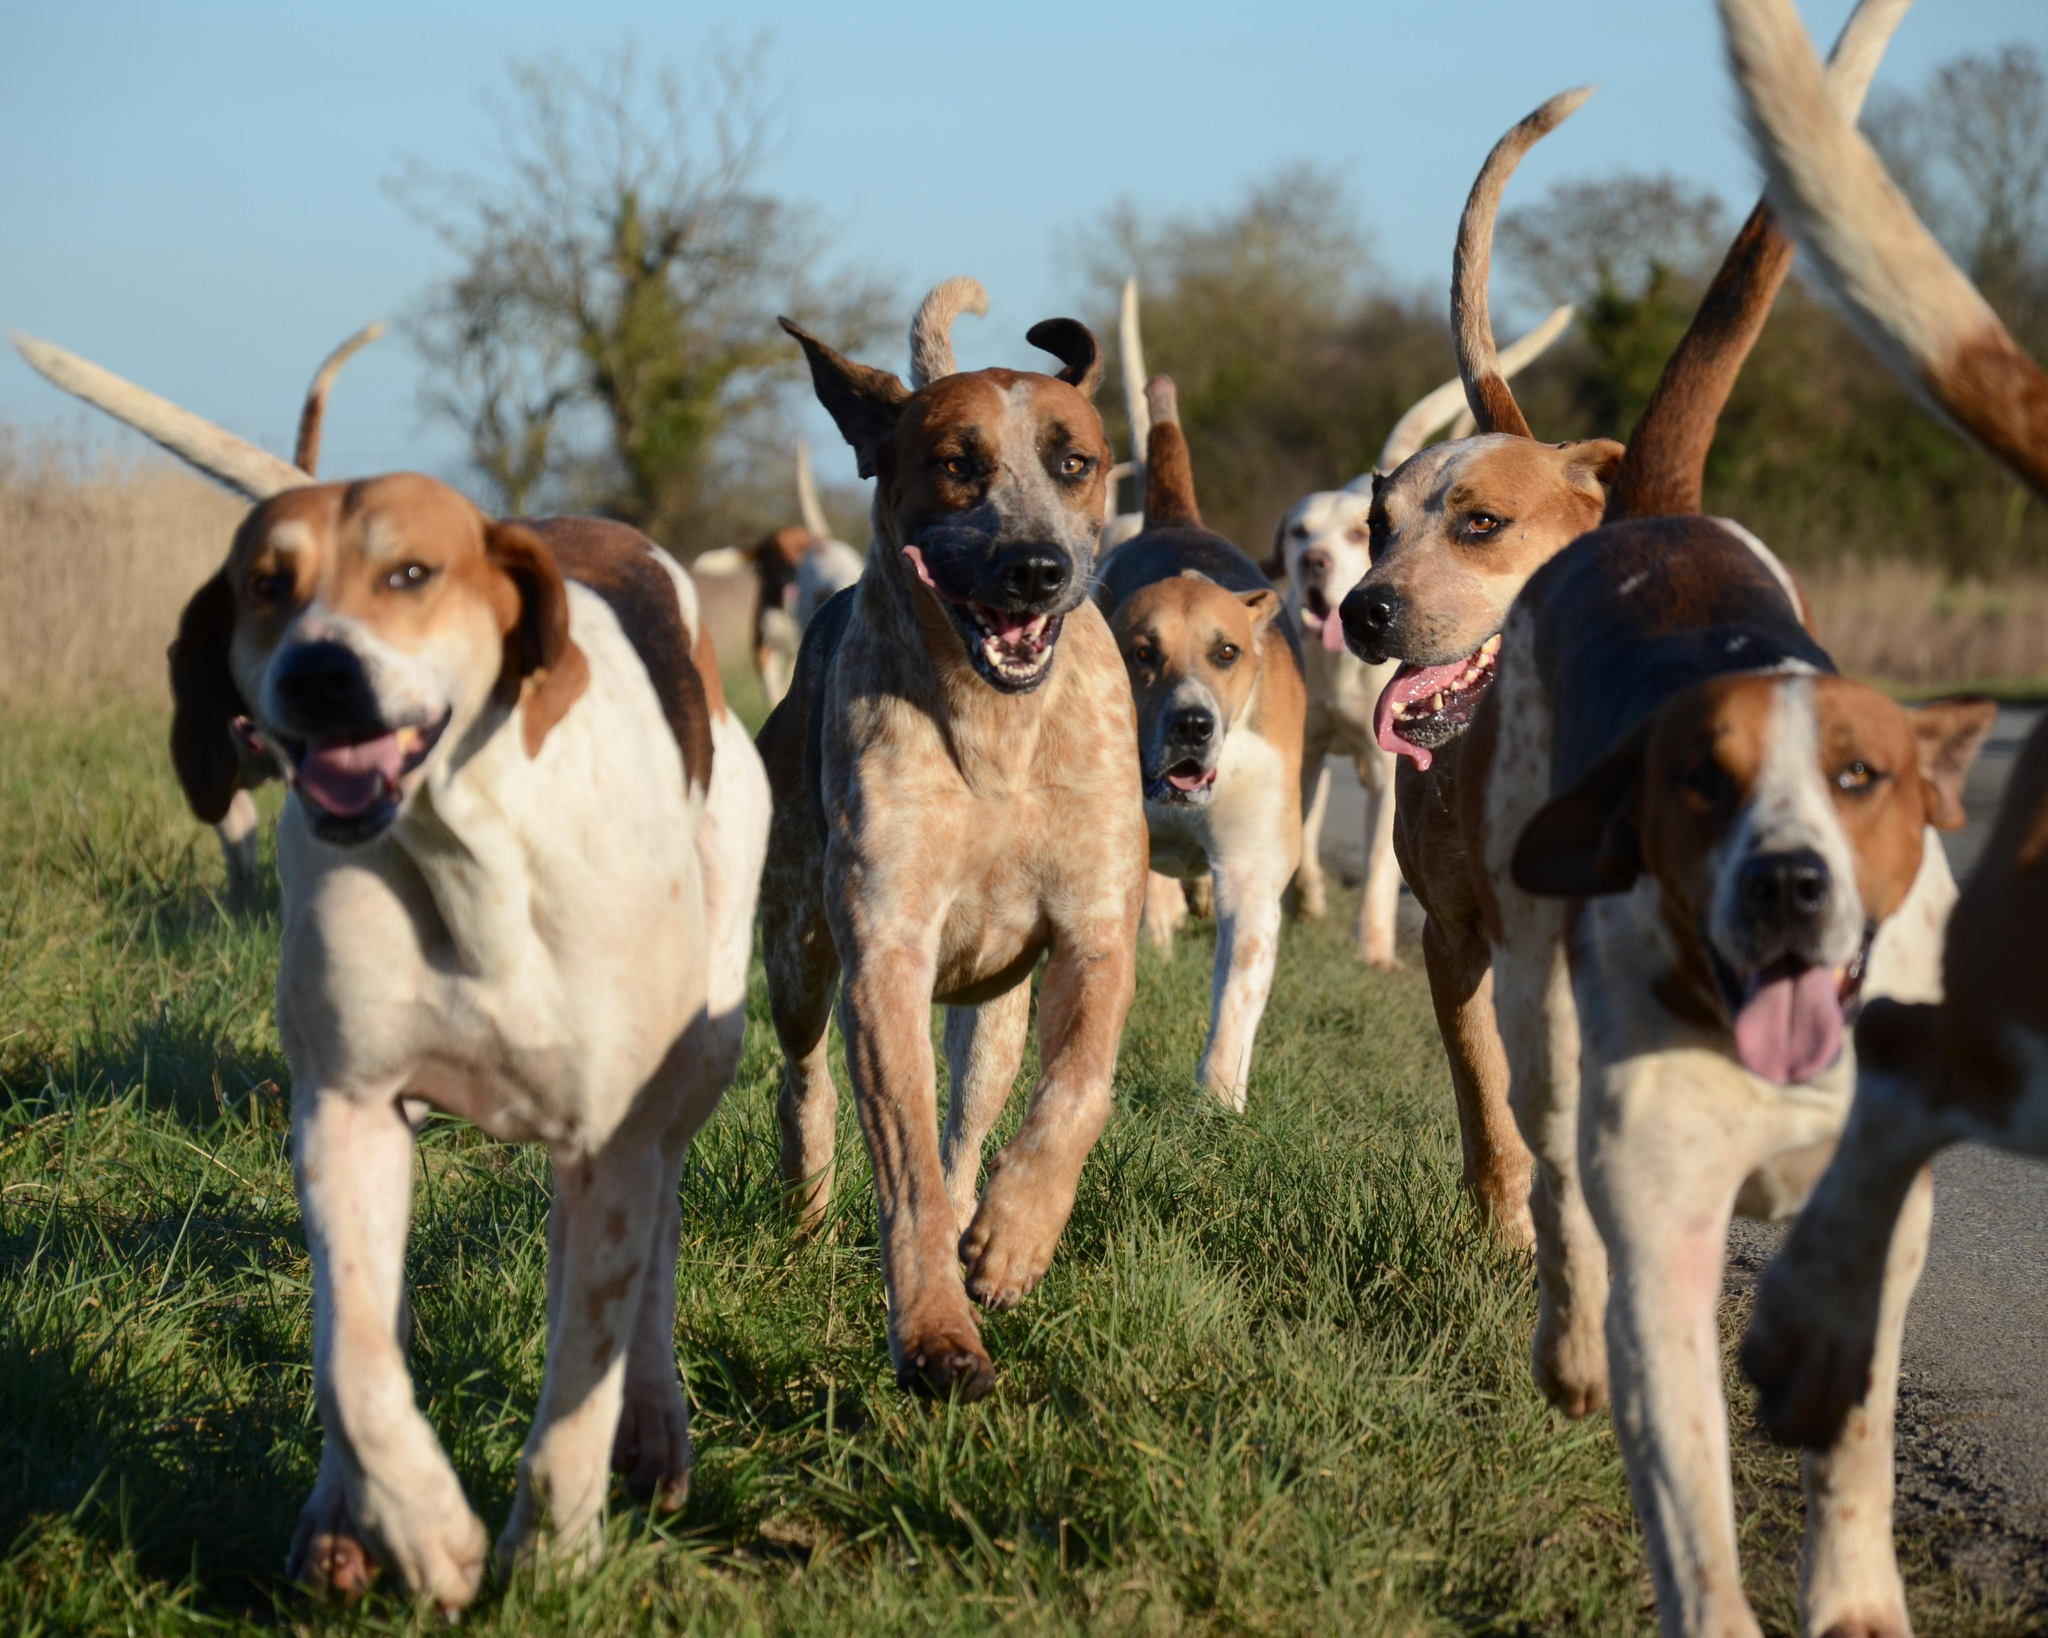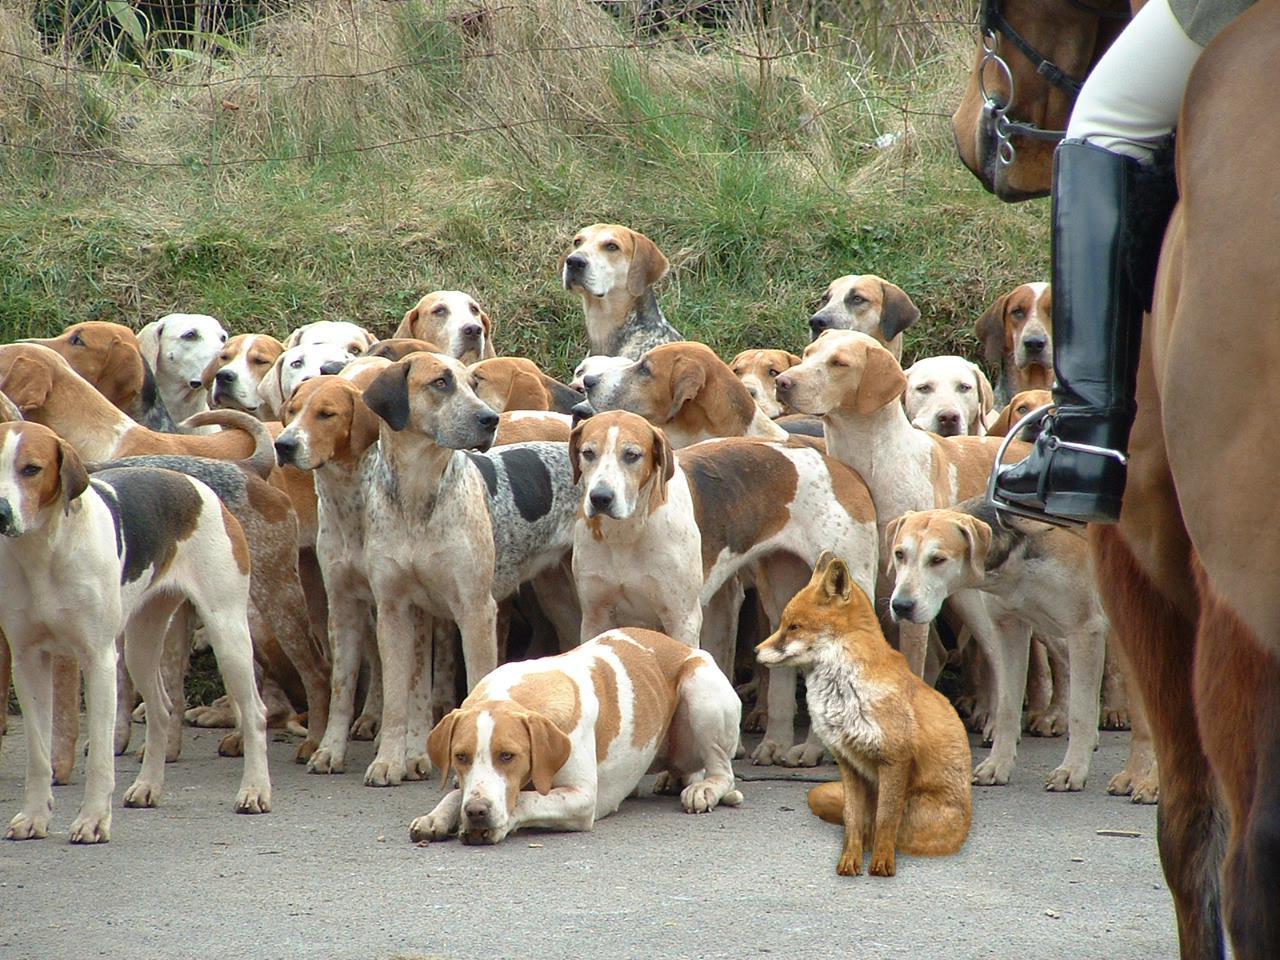The first image is the image on the left, the second image is the image on the right. Evaluate the accuracy of this statement regarding the images: "A persons leg is visible in the right image.". Is it true? Answer yes or no. Yes. The first image is the image on the left, the second image is the image on the right. For the images shown, is this caption "In one image, all dogs are running in a field." true? Answer yes or no. Yes. 